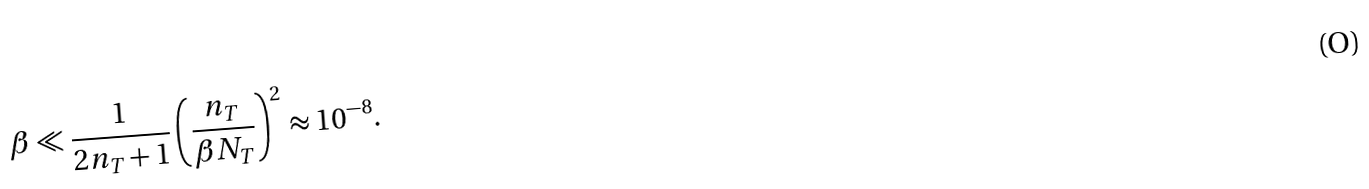<formula> <loc_0><loc_0><loc_500><loc_500>\beta \ll \frac { 1 } { 2 n _ { T } + 1 } \left ( \frac { n _ { T } } { \beta N _ { T } } \right ) ^ { 2 } \approx 1 0 ^ { - 8 } .</formula> 